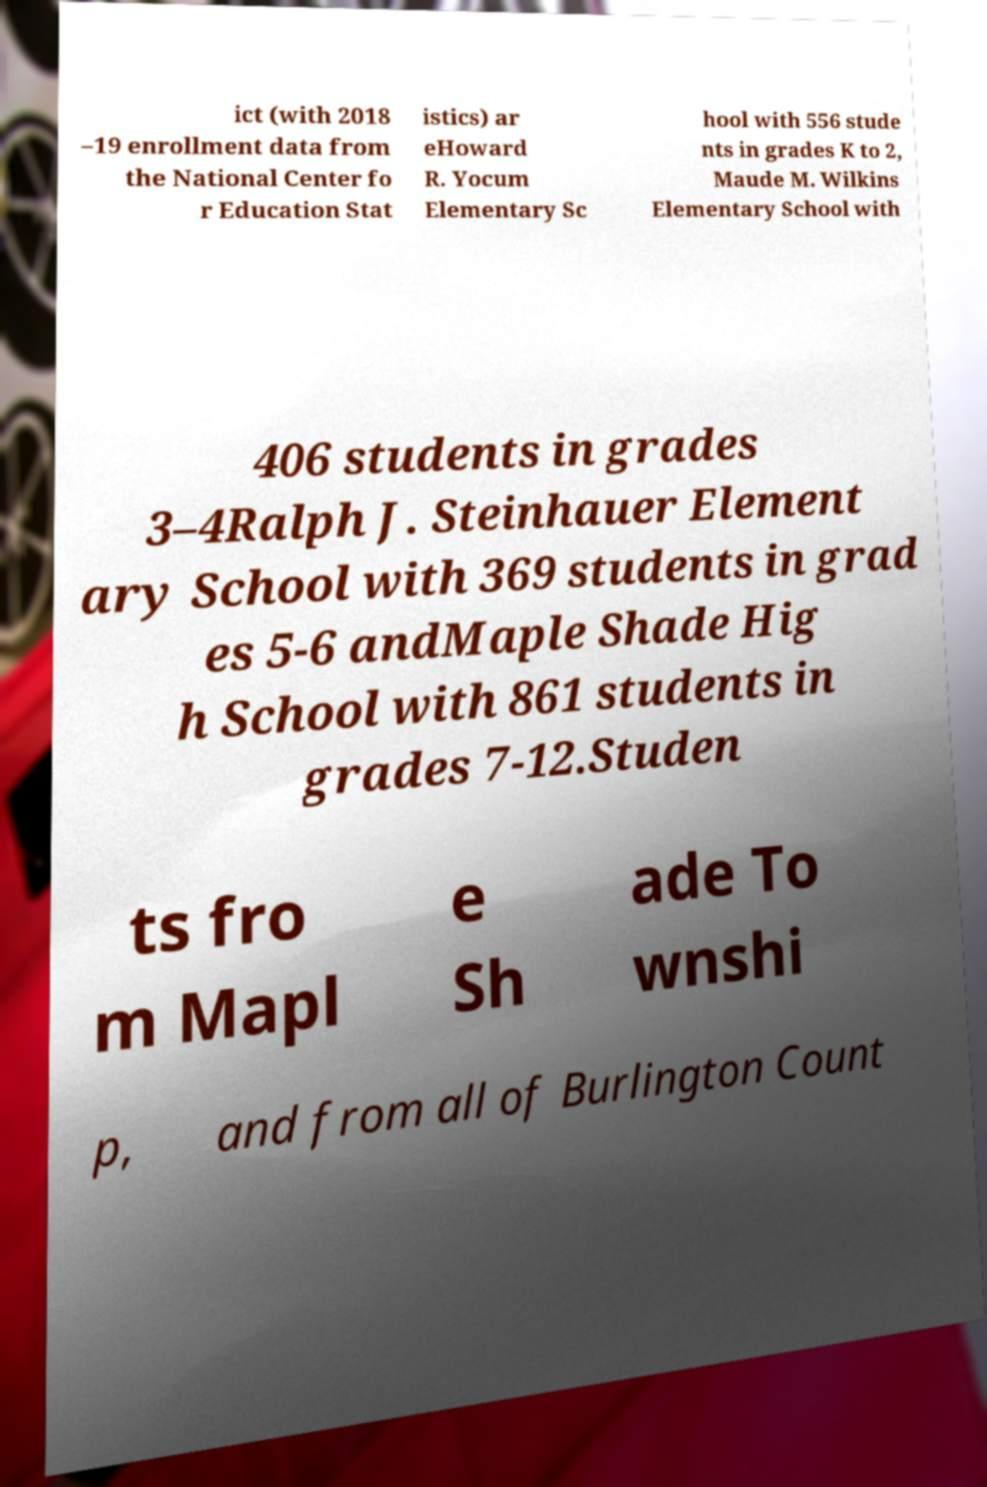Could you assist in decoding the text presented in this image and type it out clearly? ict (with 2018 –19 enrollment data from the National Center fo r Education Stat istics) ar eHoward R. Yocum Elementary Sc hool with 556 stude nts in grades K to 2, Maude M. Wilkins Elementary School with 406 students in grades 3–4Ralph J. Steinhauer Element ary School with 369 students in grad es 5-6 andMaple Shade Hig h School with 861 students in grades 7-12.Studen ts fro m Mapl e Sh ade To wnshi p, and from all of Burlington Count 